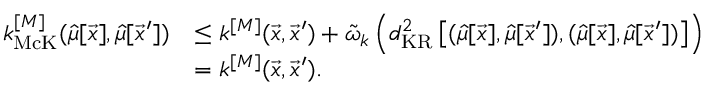Convert formula to latex. <formula><loc_0><loc_0><loc_500><loc_500>\begin{array} { r l } { k _ { M c K } ^ { [ M ] } ( \hat { \mu } [ \vec { x } ] , \hat { \mu } [ \vec { x } ^ { \prime } ] ) } & { \leq k ^ { [ M ] } ( \vec { x } , \vec { x } ^ { \prime } ) + \tilde { \omega } _ { k } \left ( d _ { K R } ^ { 2 } \left [ ( \hat { \mu } [ \vec { x } ] , \hat { \mu } [ \vec { x } ^ { \prime } ] ) , ( \hat { \mu } [ \vec { x } ] , \hat { \mu } [ \vec { x } ^ { \prime } ] ) \right ] \right ) } \\ & { = k ^ { [ M ] } ( \vec { x } , \vec { x } ^ { \prime } ) . } \end{array}</formula> 